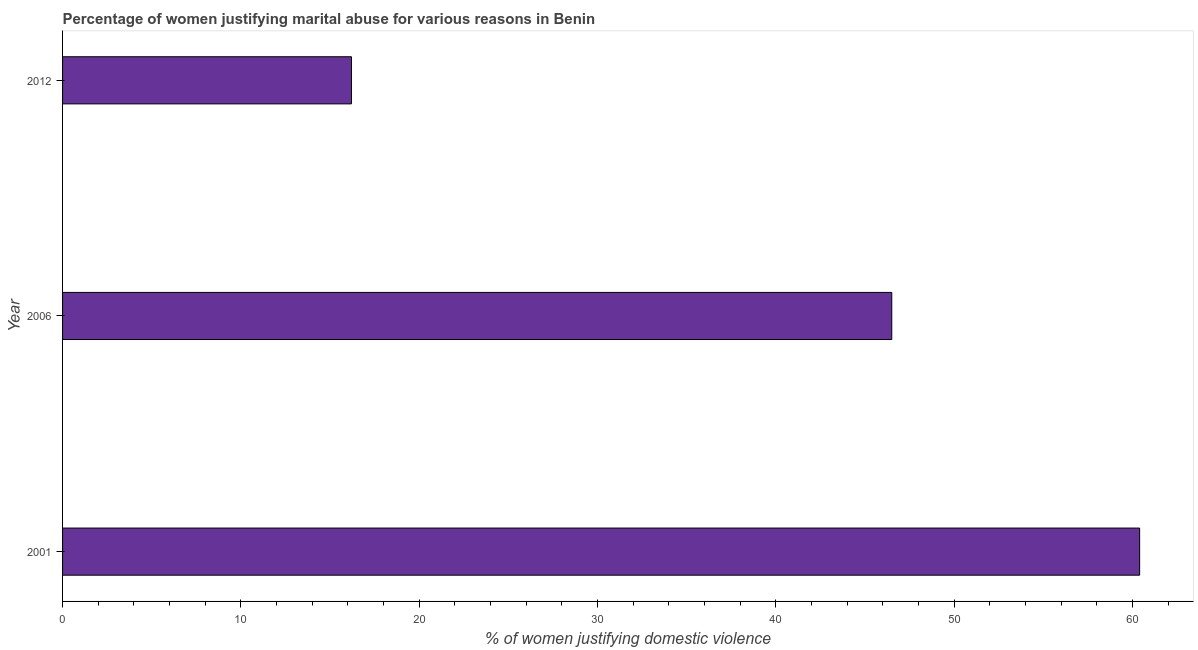Does the graph contain any zero values?
Your response must be concise. No. Does the graph contain grids?
Your answer should be very brief. No. What is the title of the graph?
Provide a succinct answer. Percentage of women justifying marital abuse for various reasons in Benin. What is the label or title of the X-axis?
Provide a short and direct response. % of women justifying domestic violence. What is the label or title of the Y-axis?
Provide a short and direct response. Year. What is the percentage of women justifying marital abuse in 2001?
Provide a succinct answer. 60.4. Across all years, what is the maximum percentage of women justifying marital abuse?
Your answer should be compact. 60.4. What is the sum of the percentage of women justifying marital abuse?
Your answer should be compact. 123.1. What is the difference between the percentage of women justifying marital abuse in 2006 and 2012?
Keep it short and to the point. 30.3. What is the average percentage of women justifying marital abuse per year?
Provide a short and direct response. 41.03. What is the median percentage of women justifying marital abuse?
Offer a very short reply. 46.5. What is the ratio of the percentage of women justifying marital abuse in 2006 to that in 2012?
Your response must be concise. 2.87. Is the difference between the percentage of women justifying marital abuse in 2001 and 2006 greater than the difference between any two years?
Provide a short and direct response. No. What is the difference between the highest and the second highest percentage of women justifying marital abuse?
Offer a terse response. 13.9. Is the sum of the percentage of women justifying marital abuse in 2001 and 2012 greater than the maximum percentage of women justifying marital abuse across all years?
Offer a very short reply. Yes. What is the difference between the highest and the lowest percentage of women justifying marital abuse?
Provide a succinct answer. 44.2. Are all the bars in the graph horizontal?
Provide a succinct answer. Yes. How many years are there in the graph?
Provide a succinct answer. 3. What is the difference between two consecutive major ticks on the X-axis?
Your answer should be compact. 10. Are the values on the major ticks of X-axis written in scientific E-notation?
Your response must be concise. No. What is the % of women justifying domestic violence in 2001?
Give a very brief answer. 60.4. What is the % of women justifying domestic violence in 2006?
Your answer should be compact. 46.5. What is the % of women justifying domestic violence of 2012?
Keep it short and to the point. 16.2. What is the difference between the % of women justifying domestic violence in 2001 and 2012?
Ensure brevity in your answer.  44.2. What is the difference between the % of women justifying domestic violence in 2006 and 2012?
Make the answer very short. 30.3. What is the ratio of the % of women justifying domestic violence in 2001 to that in 2006?
Provide a succinct answer. 1.3. What is the ratio of the % of women justifying domestic violence in 2001 to that in 2012?
Make the answer very short. 3.73. What is the ratio of the % of women justifying domestic violence in 2006 to that in 2012?
Make the answer very short. 2.87. 